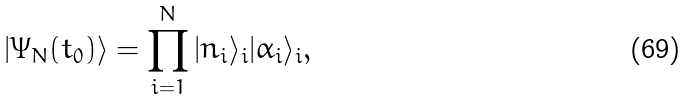Convert formula to latex. <formula><loc_0><loc_0><loc_500><loc_500>| \Psi _ { N } ( t _ { 0 } ) \rangle = \prod _ { i = 1 } ^ { N } | { n } _ { i } \rangle _ { i } | \alpha _ { i } \rangle _ { i } ,</formula> 